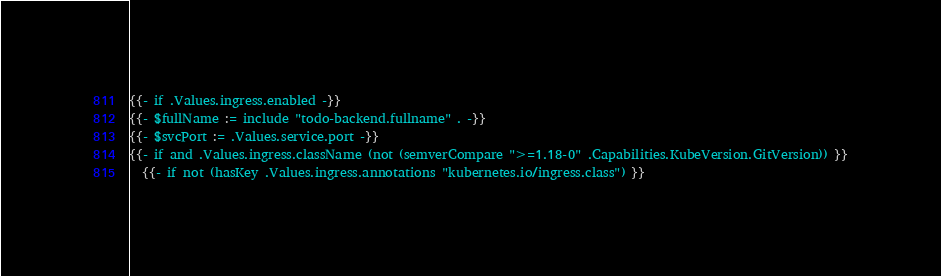<code> <loc_0><loc_0><loc_500><loc_500><_YAML_>{{- if .Values.ingress.enabled -}}
{{- $fullName := include "todo-backend.fullname" . -}}
{{- $svcPort := .Values.service.port -}}
{{- if and .Values.ingress.className (not (semverCompare ">=1.18-0" .Capabilities.KubeVersion.GitVersion)) }}
  {{- if not (hasKey .Values.ingress.annotations "kubernetes.io/ingress.class") }}</code> 